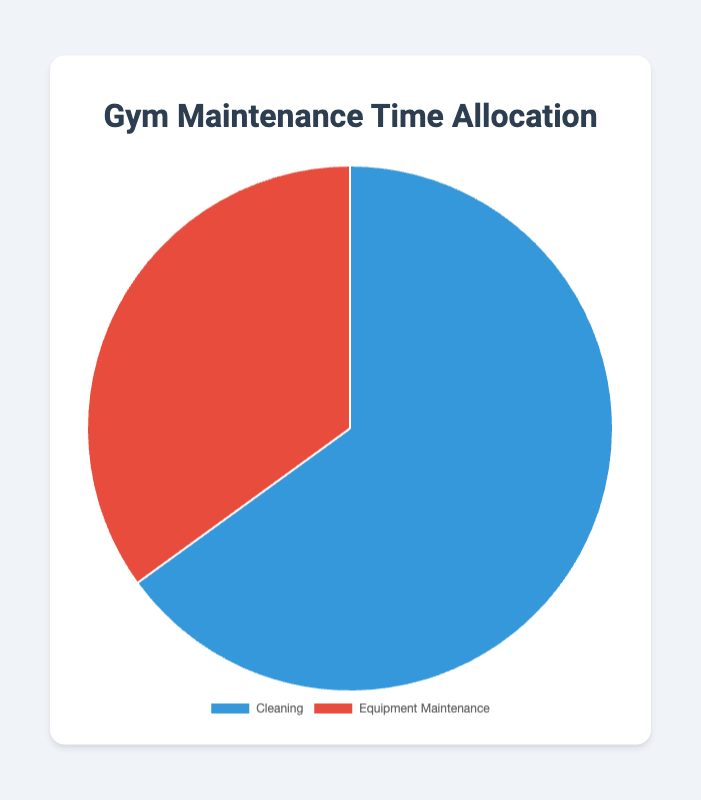What percentage of time is spent on cleaning? The pie chart shows two categories: "Cleaning" and "Equipment Maintenance," and the data segment labeled "Cleaning" corresponds to 65%.
Answer: 65% What is the percentage difference between cleaning and equipment maintenance? Cleaning is 65% and Equipment Maintenance is 35%. The percentage difference is 65% - 35% = 30%.
Answer: 30% Which activity takes up more time, cleaning or equipment maintenance? The visual representation shows that the segment for cleaning is larger than that for equipment maintenance, and the percentages are 65% and 35%, respectively. Therefore, cleaning takes up more time.
Answer: Cleaning What color represents equipment maintenance in the pie chart? The pie chart uses visual colors to distinguish between segments, and the segment for Equipment Maintenance is colored red.
Answer: Red If the combined time spent is 100 hours, how many hours are spent on cleaning? The pie chart indicates that 65% of the time is spent on cleaning. Therefore, 65% of 100 hours = 0.65 * 100 = 65 hours.
Answer: 65 hours How much more time is spent on cleaning than on equipment maintenance in terms of percentage? The pie chart shows cleaning is 65% and equipment maintenance is 35%. The percentage difference is 65% - 35% = 30%.
Answer: 30% What would be the ratio of time spent on cleaning to that spent on equipment maintenance? Since 65% of the time is spent on cleaning and 35% on equipment maintenance, the ratio is 65%:35%, which simplifies to 65:35 = 13:7.
Answer: 13:7 